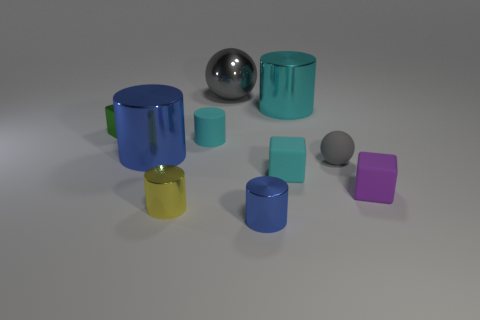Can you describe the layout of the objects in the image? Sure, the image showcases an assortment of geometric shapes and objects arranged on a flat surface. There's a diversity of colors and materials, including cylinders in cyan, blue, and yellow, a gray sphere with a reflective surface, two cubes—one purple and one blue-green—and a green mug with a handle. They're all placed against a non-descript, neutral-toned backdrop, giving the composition a minimalistic feel. 